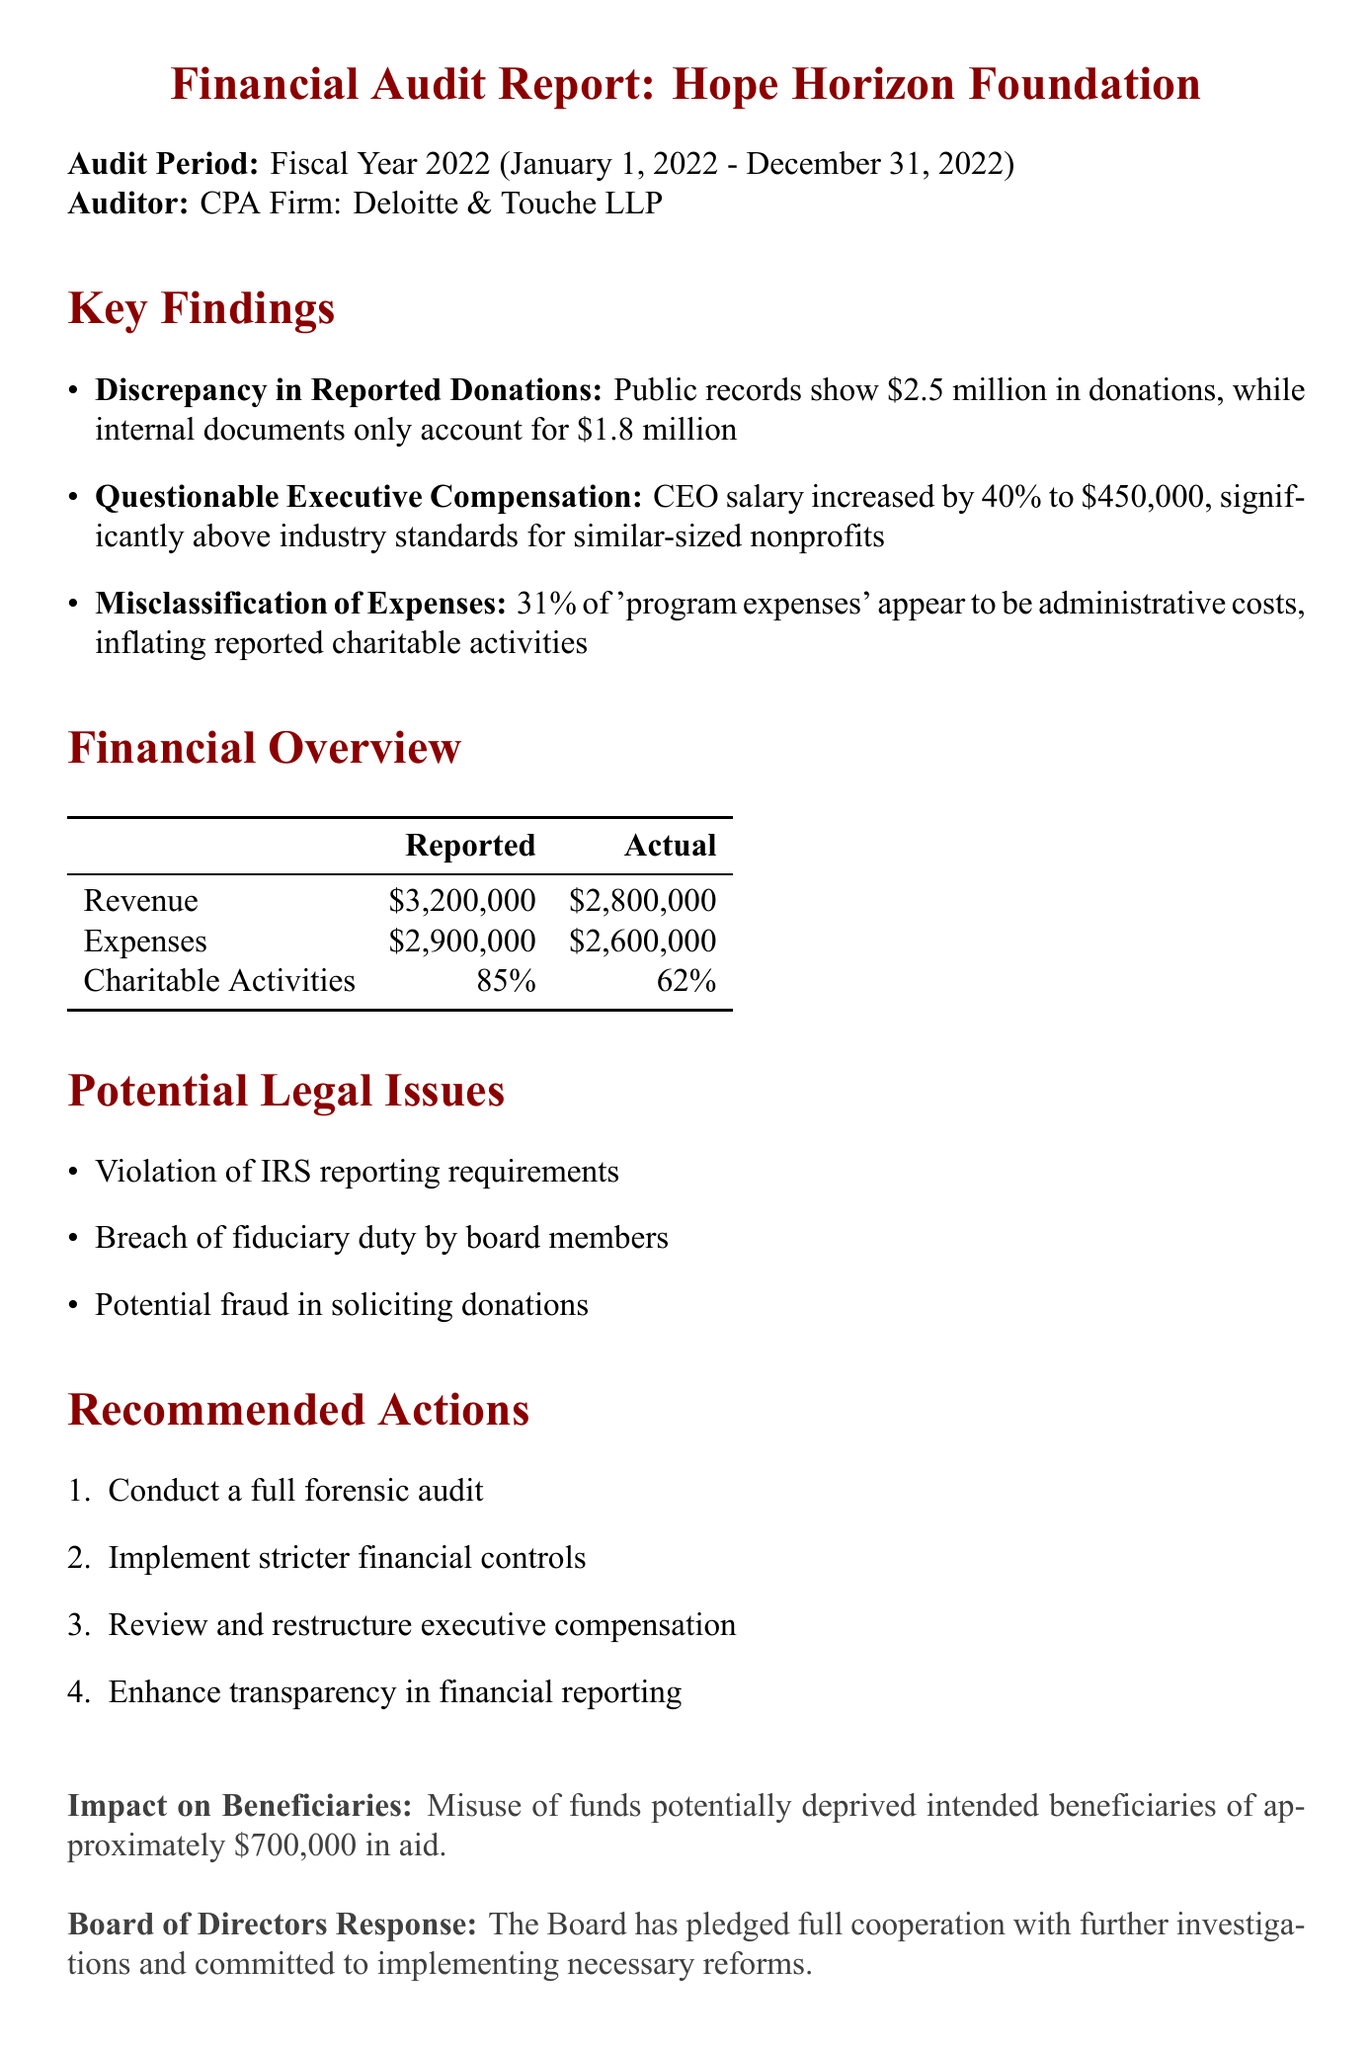What is the total reported revenue? The reported revenue is stated in the financial overview section of the document as $3,200,000.
Answer: $3,200,000 What is the CEO's salary? The document states the CEO's salary is $450,000, as indicated in the key findings under questionable executive compensation.
Answer: $450,000 What percentage of actual charitable activities is reported? The reported percentage of charitable activities is listed in the financial overview as 85%.
Answer: 85% How much money potentially deprived beneficiaries? The impact on beneficiaries section indicates that approximately $700,000 in aid was deprived due to misuse of funds.
Answer: $700,000 What is the recommended action regarding financial controls? The document recommends implementing stricter financial controls as one of the necessary reforms.
Answer: Stricter financial controls What discrepancy exists in reported donations? The key findings section presents a discrepancy where public records show $2.5 million, while internal documents only account for $1.8 million.
Answer: $2.5 million and $1.8 million What percentage of 'program expenses' are misclassified? It is stated in the key findings that 31% of 'program expenses' appear to be administrative costs.
Answer: 31% What potential legal issue involves board members? The document highlights a breach of fiduciary duty by board members as a potential legal issue.
Answer: Breach of fiduciary duty Who conducted the audit? The auditor firm conducting the audit is mentioned at the beginning of the document as Deloitte & Touche LLP.
Answer: Deloitte & Touche LLP 